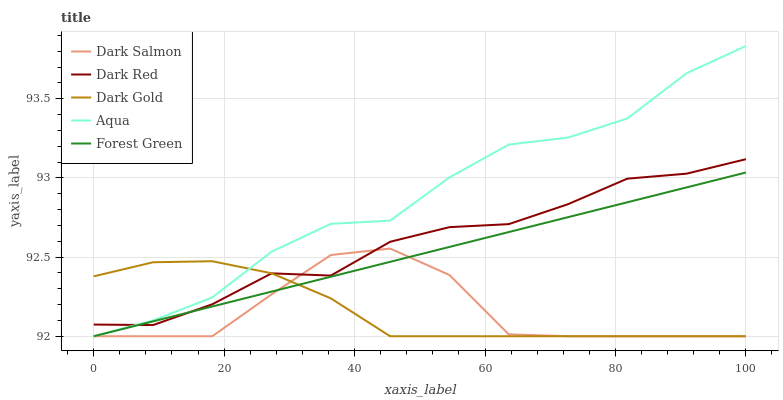Does Forest Green have the minimum area under the curve?
Answer yes or no. No. Does Forest Green have the maximum area under the curve?
Answer yes or no. No. Is Aqua the smoothest?
Answer yes or no. No. Is Forest Green the roughest?
Answer yes or no. No. Does Forest Green have the highest value?
Answer yes or no. No. 